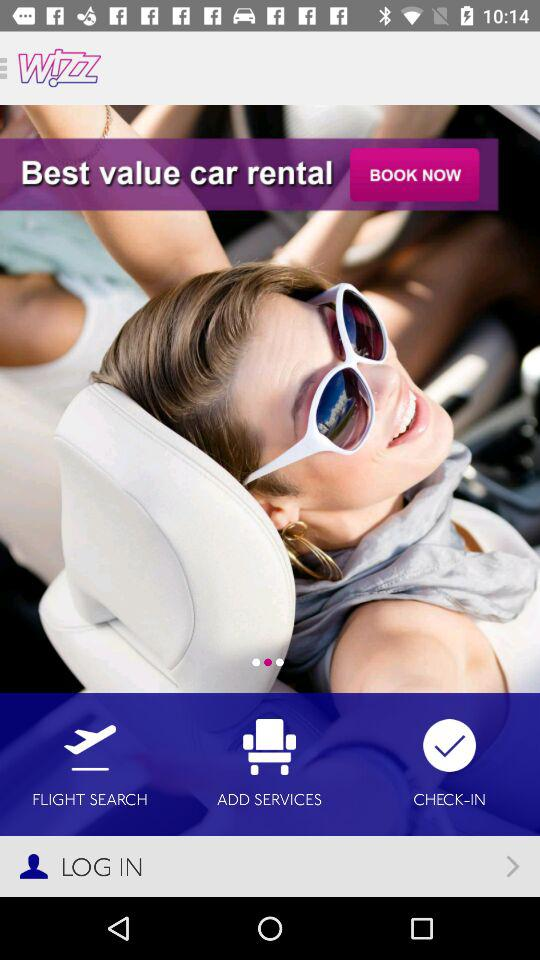What is the name of the application? The application name is "wizz". 